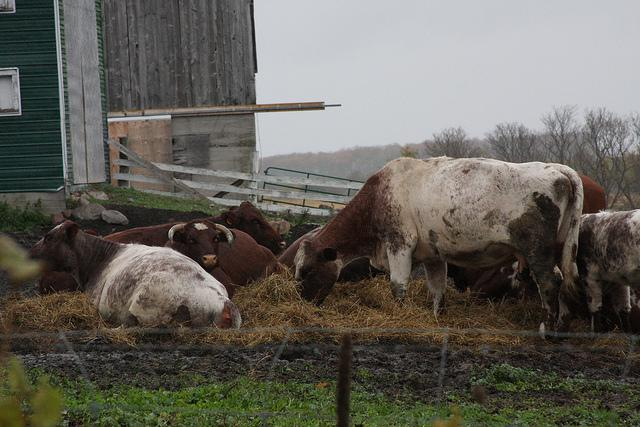The cows main food source for nutrition is brought out in what shape?

Choices:
A) boxed
B) bundles
C) taped
D) barrels barrels 